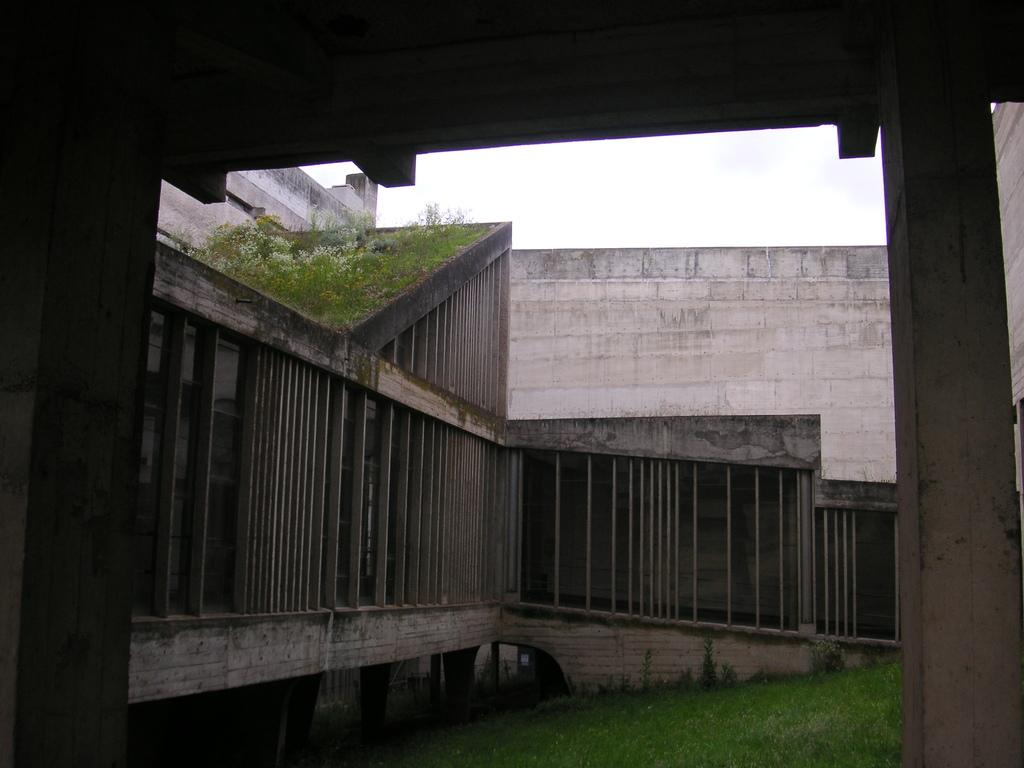What type of structure is present in the image? There is a building in the image. What else can be seen in the image besides the building? There are plants in the image. What is visible at the bottom of the image? The ground is visible at the bottom of the image. How many socks are hanging on the building in the image? There are no socks present in the image; it features a building and plants. What type of spring is visible in the image? There is no spring present in the image. 